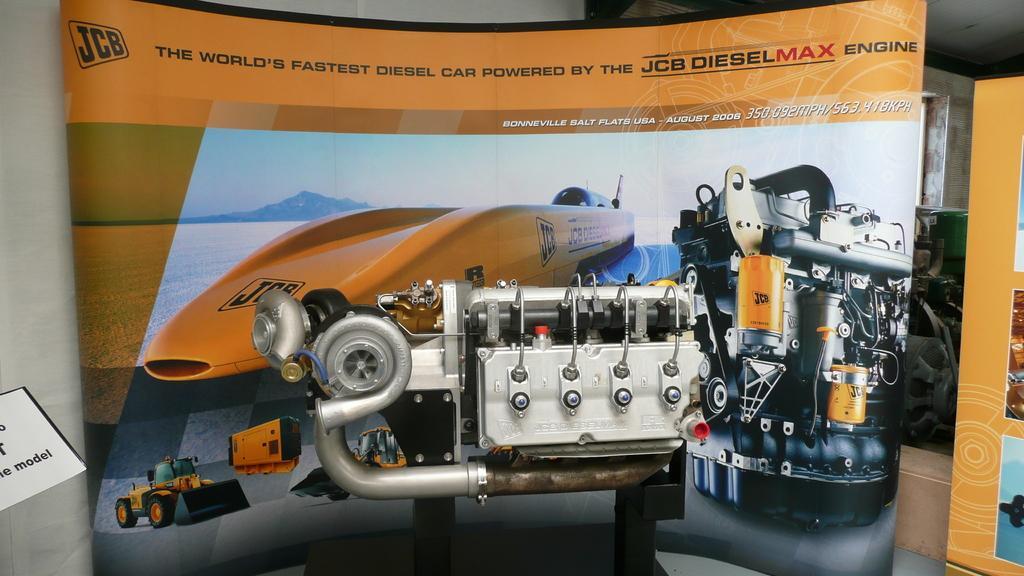Please provide a concise description of this image. This picture is clicked inside. In the center there is an orange color banner on which we can see the picture of some objects and the picture of a sky, hill and a water body and a picture of a vehicle. In the center there is a machine which is placed on the ground. In the background there are some objects placed on the ground and we can see the roof and the banners. 